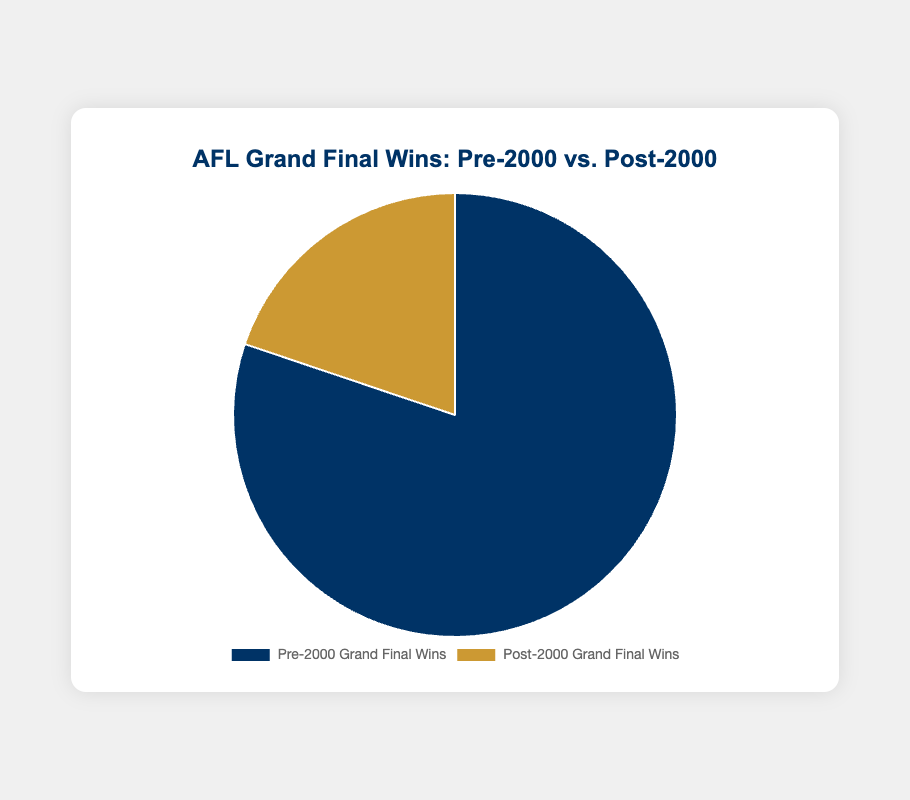How many total Grand Final wins occurred pre-2000? We sum the wins before 2000: 16 (Carlton) + 16 (Essendon) + 14 (Collingwood) + 12 (Melbourne) + 10 (Richmond) + 9 (Hawthorn) + 6 (Geelong) + 3 (South Melbourne/Sydney) + 2 (North Melbourne) + 1 (St. Kilda). The total is 89 wins.
Answer: 89 How many total Grand Final wins occurred post-2000? We sum the wins after 2000: 4 (Hawthorn) + 4 (Geelong) + 3 (Brisbane Lions) + 3 (Richmond) + 2 (Sydney Swans) + 2 (West Coast Eagles) + 1 (Port Adelaide) + 1 (Collingwood) + 1 (Essendon) + 1 (Western Bulldogs). The total is 22 wins.
Answer: 22 Which period had more Grand Final wins, pre-2000 or post-2000? Compare the two periods: pre-2000 (89 wins) vs. post-2000 (22 wins). Pre-2000 has more wins.
Answer: Pre-2000 What is the percentage of Grand Final wins that occurred post-2000? Total wins are 89 + 22 = 111. The percentage for post-2000 is (22/111) * 100 ≈ 19.82%.
Answer: 19.82% Which team has the maximum Grand Final wins pre-2000? Pre-2000 team wins: Carlton (16), Essendon (16), Collingwood (14), Melbourne (12), Richmond (10), Hawthorn (9), Geelong (6), South Melbourne/Sydney (3), North Melbourne (2), St. Kilda (1). Carlton and Essendon have the maximum wins (16 each).
Answer: Carlton and Essendon Which team has the most Grand Final wins post-2000 and how many? Post-2000 wins: Hawthorn (4), Geelong (4), Brisbane Lions (3), Richmond (3), Sydney Swans (2), West Coast Eagles (2), Port Adelaide (1), Collingwood (1), Essendon (1), Western Bulldogs (1). Both Hawthorn and Geelong have the most wins (4 each).
Answer: Hawthorn and Geelong, 4 What's the difference in wins between the team with the most pre-2000 wins and the team with the most post-2000 wins? Most pre-2000 wins: Carlton/Essendon (16 each). Most post-2000 wins: Hawthorn/Geelong (4 each). The difference is 16 - 4 = 12 wins.
Answer: 12 What proportion of total wins did Carlton and Essendon achieve together pre-2000? Combined wins of Carlton and Essendon pre-2000: 16 + 16 = 32. Total wins pre-2000: 89. The proportion is 32/89 ≈ 0.359.
Answer: 0.359 Which period had the highest variety of different winning teams? Pre-2000 had 10 different winning teams. Post-2000 also had 10 different winning teams. Both periods have the same variety.
Answer: Both periods How many teams won more than 10 Grand Finals in total (both periods combined)? Examine combined totals: Carlton (16), Essendon (17), Collingwood (15), Melbourne (12), Richmond (13), Hawthorn (13), Geelong (10), and others below 10. Four teams have more than 10 wins: Carlton, Essendon, Collingwood, Melbourne, Richmond.
Answer: Five 